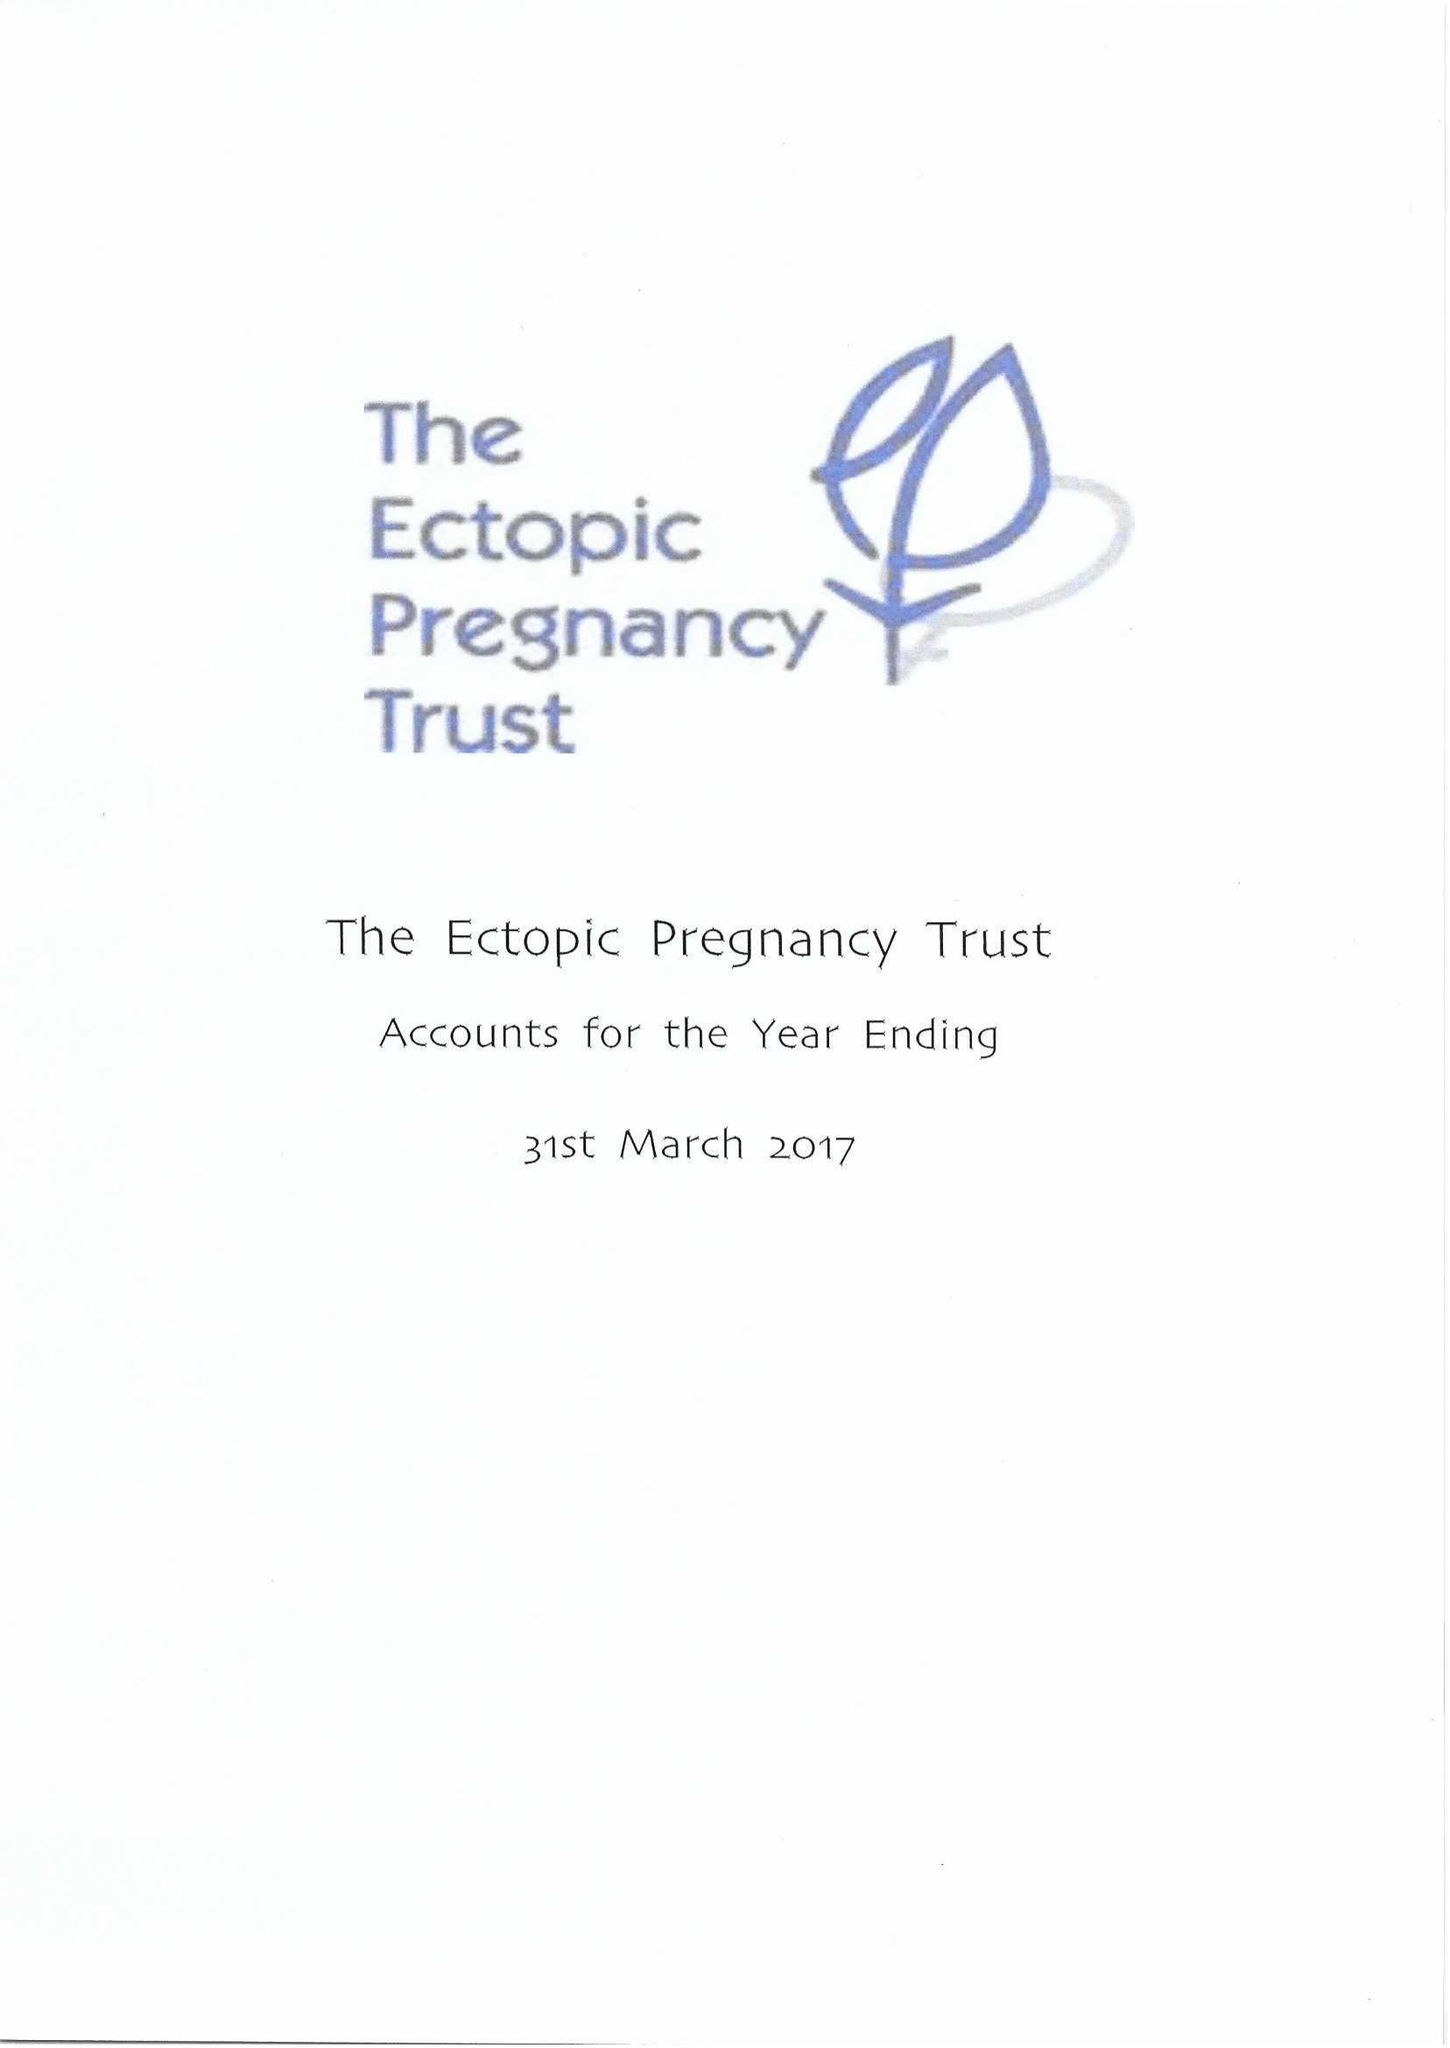What is the value for the report_date?
Answer the question using a single word or phrase. 2017-03-31 